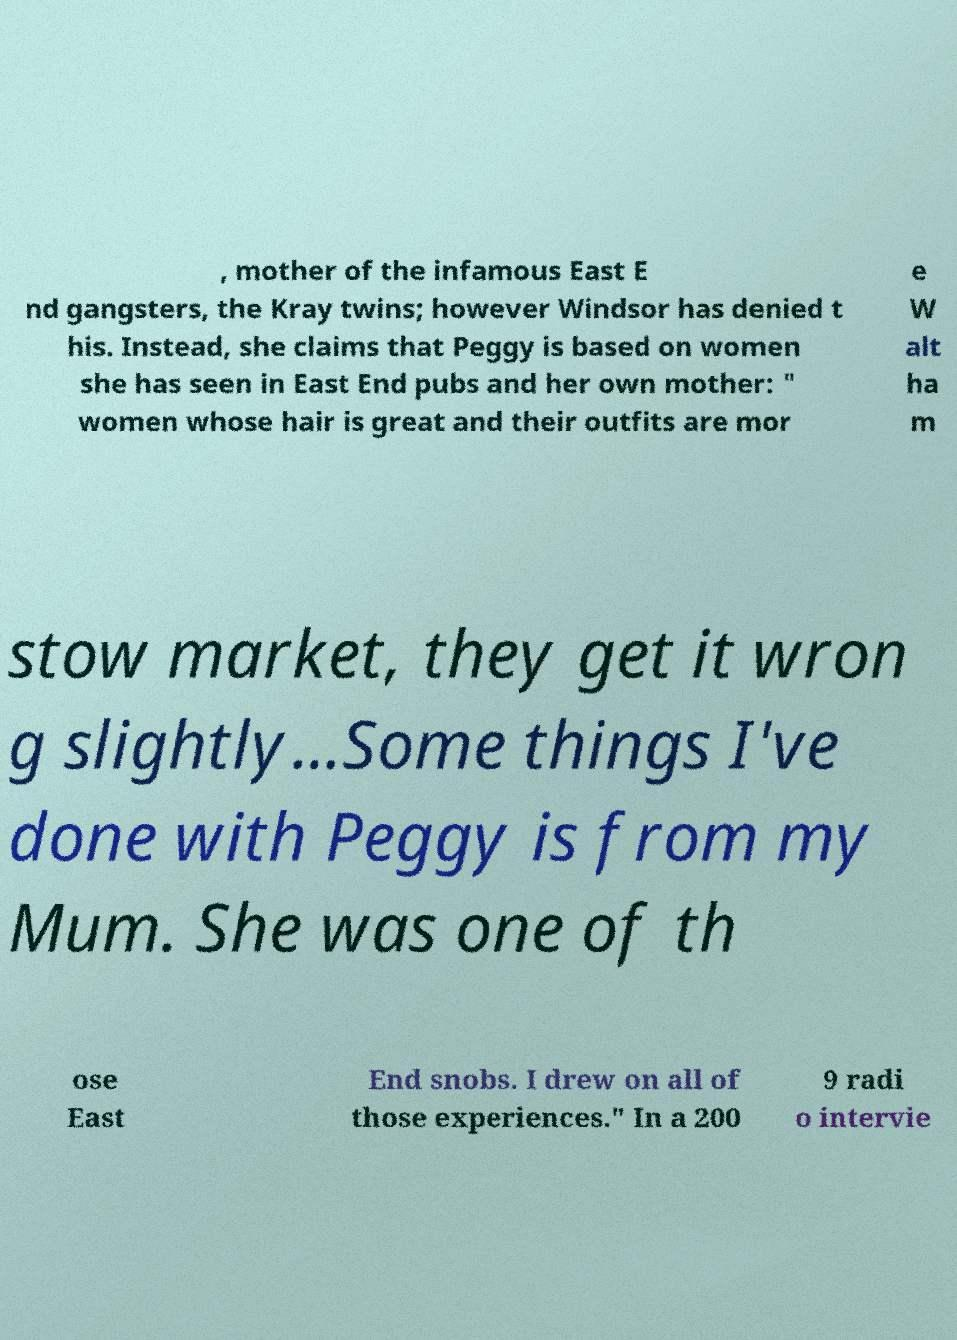Could you extract and type out the text from this image? , mother of the infamous East E nd gangsters, the Kray twins; however Windsor has denied t his. Instead, she claims that Peggy is based on women she has seen in East End pubs and her own mother: " women whose hair is great and their outfits are mor e W alt ha m stow market, they get it wron g slightly...Some things I've done with Peggy is from my Mum. She was one of th ose East End snobs. I drew on all of those experiences." In a 200 9 radi o intervie 